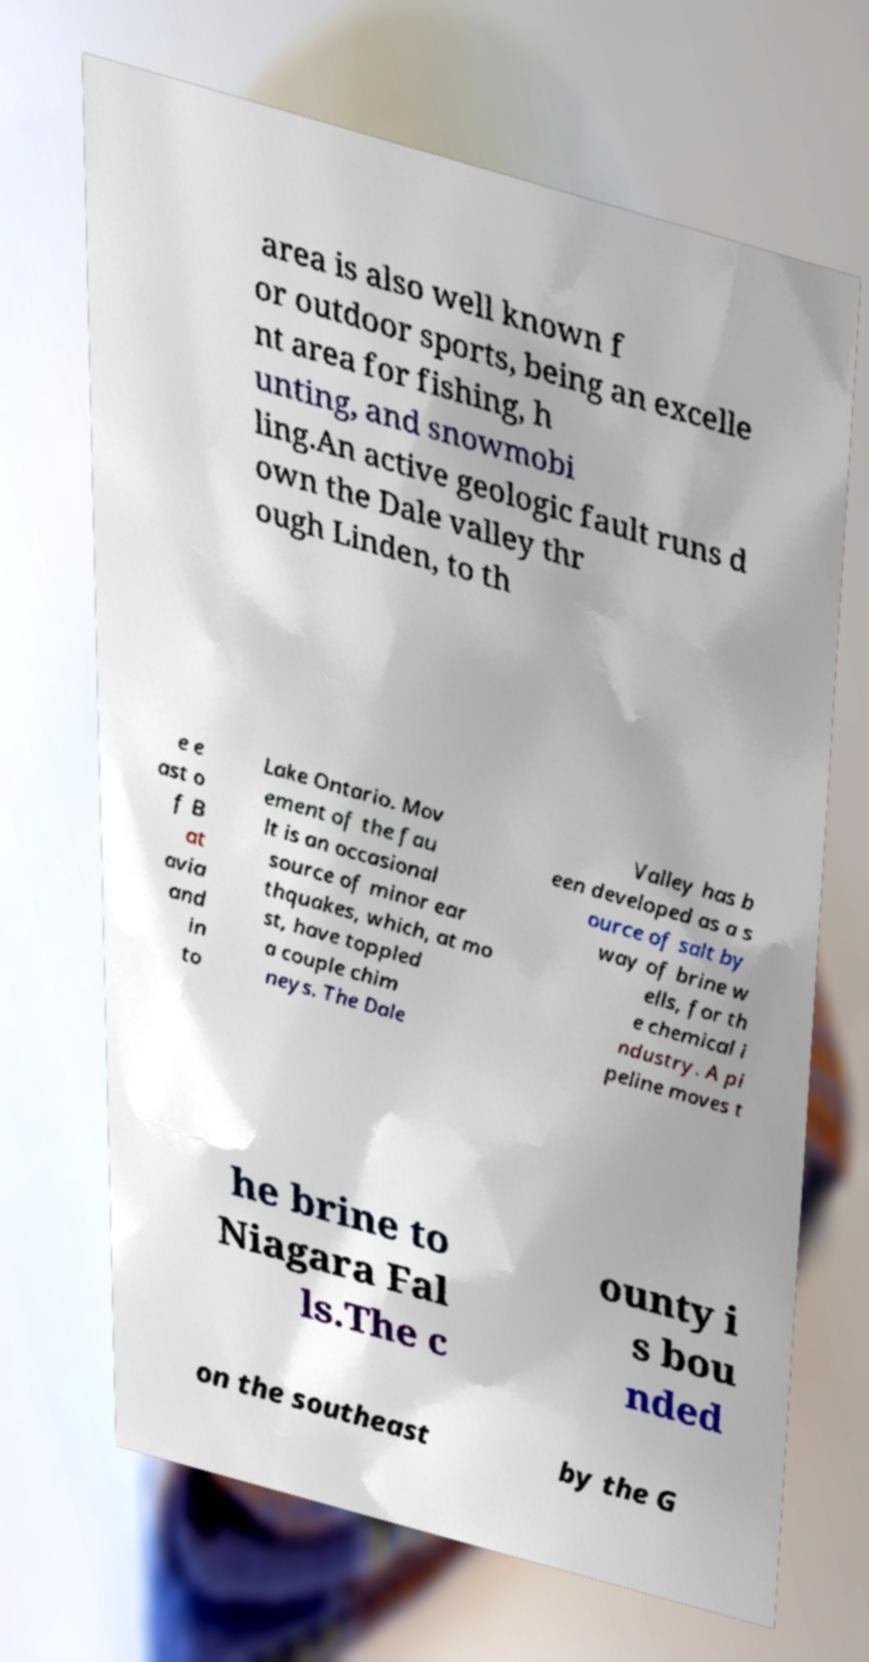Could you assist in decoding the text presented in this image and type it out clearly? area is also well known f or outdoor sports, being an excelle nt area for fishing, h unting, and snowmobi ling.An active geologic fault runs d own the Dale valley thr ough Linden, to th e e ast o f B at avia and in to Lake Ontario. Mov ement of the fau lt is an occasional source of minor ear thquakes, which, at mo st, have toppled a couple chim neys. The Dale Valley has b een developed as a s ource of salt by way of brine w ells, for th e chemical i ndustry. A pi peline moves t he brine to Niagara Fal ls.The c ounty i s bou nded on the southeast by the G 